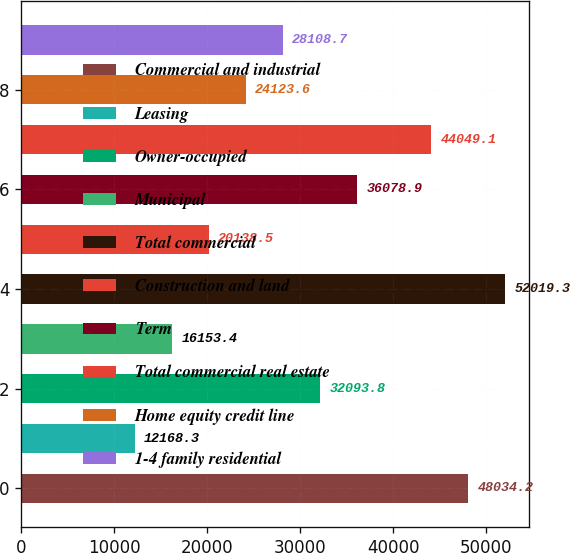Convert chart. <chart><loc_0><loc_0><loc_500><loc_500><bar_chart><fcel>Commercial and industrial<fcel>Leasing<fcel>Owner-occupied<fcel>Municipal<fcel>Total commercial<fcel>Construction and land<fcel>Term<fcel>Total commercial real estate<fcel>Home equity credit line<fcel>1-4 family residential<nl><fcel>48034.2<fcel>12168.3<fcel>32093.8<fcel>16153.4<fcel>52019.3<fcel>20138.5<fcel>36078.9<fcel>44049.1<fcel>24123.6<fcel>28108.7<nl></chart> 